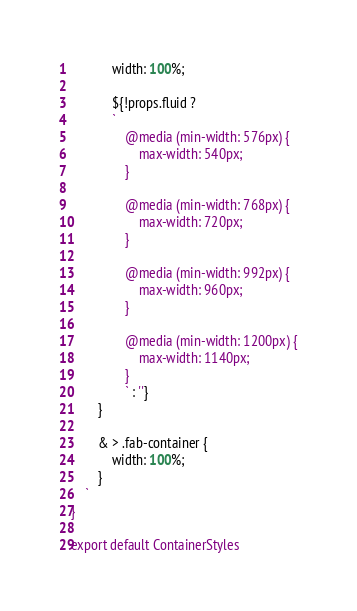<code> <loc_0><loc_0><loc_500><loc_500><_JavaScript_>            width: 100%;

            ${!props.fluid ?
            `
                @media (min-width: 576px) {
                    max-width: 540px;
                }
                
                @media (min-width: 768px) {
                    max-width: 720px;
                }

                @media (min-width: 992px) {
                    max-width: 960px;
                }

                @media (min-width: 1200px) {
                    max-width: 1140px;
                }
                ` : ''}
        }

        & > .fab-container {
            width: 100%;
        }
    `
}

export default ContainerStyles</code> 